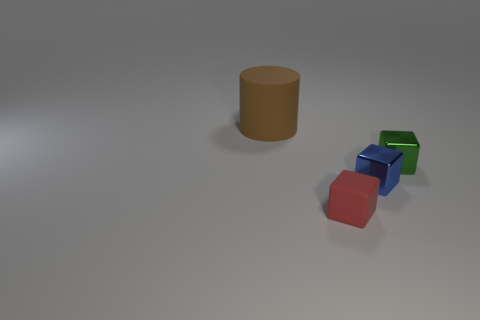How big is the red block?
Your answer should be very brief. Small. There is a rubber thing that is left of the red matte object; is it the same color as the small rubber cube?
Offer a very short reply. No. Is the number of matte cylinders that are on the left side of the brown object greater than the number of large brown rubber objects that are in front of the green metal cube?
Offer a terse response. No. Is the number of big matte cylinders greater than the number of small brown matte cubes?
Provide a short and direct response. Yes. There is a object that is both left of the blue metal object and in front of the large thing; what size is it?
Provide a short and direct response. Small. The blue object is what shape?
Keep it short and to the point. Cube. Are there any other things that have the same size as the green object?
Keep it short and to the point. Yes. Are there more objects behind the tiny green shiny cube than large things?
Keep it short and to the point. No. There is a matte object that is behind the matte object to the right of the rubber thing that is left of the small red matte object; what is its shape?
Your response must be concise. Cylinder. There is a matte thing that is to the right of the brown matte object; does it have the same size as the tiny blue thing?
Give a very brief answer. Yes. 